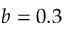<formula> <loc_0><loc_0><loc_500><loc_500>b = 0 . 3</formula> 